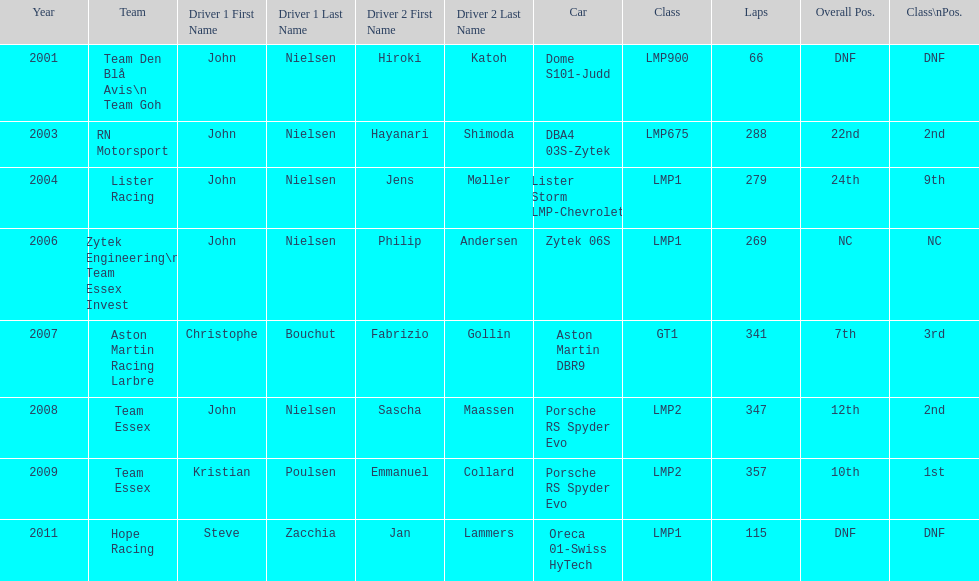What is the amount races that were competed in? 8. 